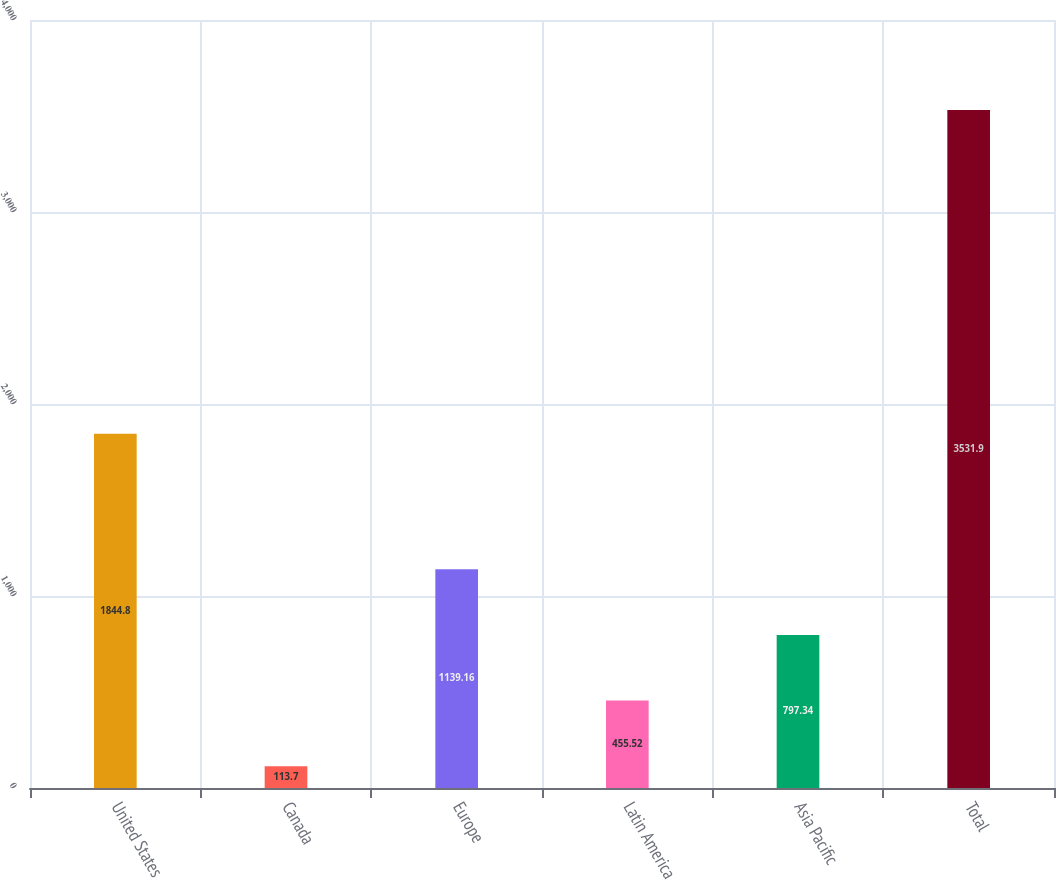Convert chart. <chart><loc_0><loc_0><loc_500><loc_500><bar_chart><fcel>United States<fcel>Canada<fcel>Europe<fcel>Latin America<fcel>Asia Pacific<fcel>Total<nl><fcel>1844.8<fcel>113.7<fcel>1139.16<fcel>455.52<fcel>797.34<fcel>3531.9<nl></chart> 